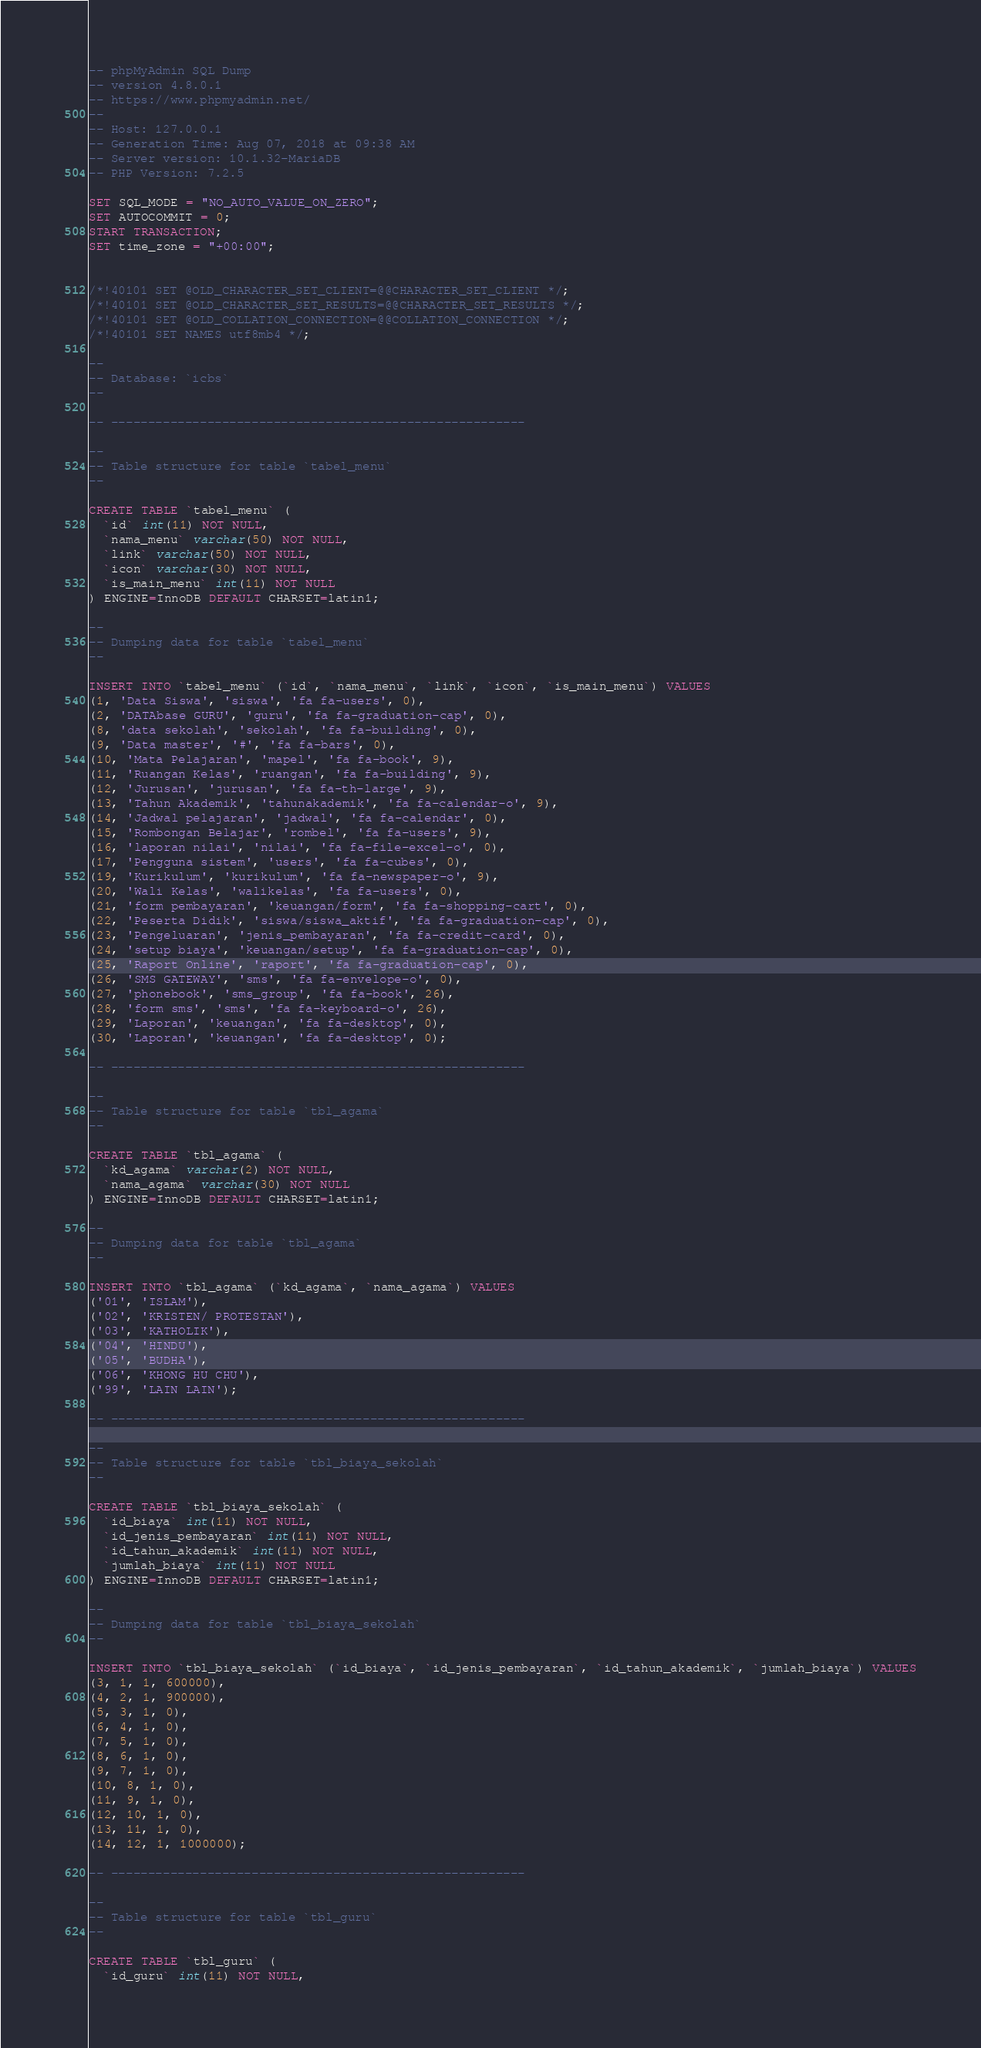<code> <loc_0><loc_0><loc_500><loc_500><_SQL_>-- phpMyAdmin SQL Dump
-- version 4.8.0.1
-- https://www.phpmyadmin.net/
--
-- Host: 127.0.0.1
-- Generation Time: Aug 07, 2018 at 09:38 AM
-- Server version: 10.1.32-MariaDB
-- PHP Version: 7.2.5

SET SQL_MODE = "NO_AUTO_VALUE_ON_ZERO";
SET AUTOCOMMIT = 0;
START TRANSACTION;
SET time_zone = "+00:00";


/*!40101 SET @OLD_CHARACTER_SET_CLIENT=@@CHARACTER_SET_CLIENT */;
/*!40101 SET @OLD_CHARACTER_SET_RESULTS=@@CHARACTER_SET_RESULTS */;
/*!40101 SET @OLD_COLLATION_CONNECTION=@@COLLATION_CONNECTION */;
/*!40101 SET NAMES utf8mb4 */;

--
-- Database: `icbs`
--

-- --------------------------------------------------------

--
-- Table structure for table `tabel_menu`
--

CREATE TABLE `tabel_menu` (
  `id` int(11) NOT NULL,
  `nama_menu` varchar(50) NOT NULL,
  `link` varchar(50) NOT NULL,
  `icon` varchar(30) NOT NULL,
  `is_main_menu` int(11) NOT NULL
) ENGINE=InnoDB DEFAULT CHARSET=latin1;

--
-- Dumping data for table `tabel_menu`
--

INSERT INTO `tabel_menu` (`id`, `nama_menu`, `link`, `icon`, `is_main_menu`) VALUES
(1, 'Data Siswa', 'siswa', 'fa fa-users', 0),
(2, 'DATAbase GURU', 'guru', 'fa fa-graduation-cap', 0),
(8, 'data sekolah', 'sekolah', 'fa fa-building', 0),
(9, 'Data master', '#', 'fa fa-bars', 0),
(10, 'Mata Pelajaran', 'mapel', 'fa fa-book', 9),
(11, 'Ruangan Kelas', 'ruangan', 'fa fa-building', 9),
(12, 'Jurusan', 'jurusan', 'fa fa-th-large', 9),
(13, 'Tahun Akademik', 'tahunakademik', 'fa fa-calendar-o', 9),
(14, 'Jadwal pelajaran', 'jadwal', 'fa fa-calendar', 0),
(15, 'Rombongan Belajar', 'rombel', 'fa fa-users', 9),
(16, 'laporan nilai', 'nilai', 'fa fa-file-excel-o', 0),
(17, 'Pengguna sistem', 'users', 'fa fa-cubes', 0),
(19, 'Kurikulum', 'kurikulum', 'fa fa-newspaper-o', 9),
(20, 'Wali Kelas', 'walikelas', 'fa fa-users', 0),
(21, 'form pembayaran', 'keuangan/form', 'fa fa-shopping-cart', 0),
(22, 'Peserta Didik', 'siswa/siswa_aktif', 'fa fa-graduation-cap', 0),
(23, 'Pengeluaran', 'jenis_pembayaran', 'fa fa-credit-card', 0),
(24, 'setup biaya', 'keuangan/setup', 'fa fa-graduation-cap', 0),
(25, 'Raport Online', 'raport', 'fa fa-graduation-cap', 0),
(26, 'SMS GATEWAY', 'sms', 'fa fa-envelope-o', 0),
(27, 'phonebook', 'sms_group', 'fa fa-book', 26),
(28, 'form sms', 'sms', 'fa fa-keyboard-o', 26),
(29, 'Laporan', 'keuangan', 'fa fa-desktop', 0),
(30, 'Laporan', 'keuangan', 'fa fa-desktop', 0);

-- --------------------------------------------------------

--
-- Table structure for table `tbl_agama`
--

CREATE TABLE `tbl_agama` (
  `kd_agama` varchar(2) NOT NULL,
  `nama_agama` varchar(30) NOT NULL
) ENGINE=InnoDB DEFAULT CHARSET=latin1;

--
-- Dumping data for table `tbl_agama`
--

INSERT INTO `tbl_agama` (`kd_agama`, `nama_agama`) VALUES
('01', 'ISLAM'),
('02', 'KRISTEN/ PROTESTAN'),
('03', 'KATHOLIK'),
('04', 'HINDU'),
('05', 'BUDHA'),
('06', 'KHONG HU CHU'),
('99', 'LAIN LAIN');

-- --------------------------------------------------------

--
-- Table structure for table `tbl_biaya_sekolah`
--

CREATE TABLE `tbl_biaya_sekolah` (
  `id_biaya` int(11) NOT NULL,
  `id_jenis_pembayaran` int(11) NOT NULL,
  `id_tahun_akademik` int(11) NOT NULL,
  `jumlah_biaya` int(11) NOT NULL
) ENGINE=InnoDB DEFAULT CHARSET=latin1;

--
-- Dumping data for table `tbl_biaya_sekolah`
--

INSERT INTO `tbl_biaya_sekolah` (`id_biaya`, `id_jenis_pembayaran`, `id_tahun_akademik`, `jumlah_biaya`) VALUES
(3, 1, 1, 600000),
(4, 2, 1, 900000),
(5, 3, 1, 0),
(6, 4, 1, 0),
(7, 5, 1, 0),
(8, 6, 1, 0),
(9, 7, 1, 0),
(10, 8, 1, 0),
(11, 9, 1, 0),
(12, 10, 1, 0),
(13, 11, 1, 0),
(14, 12, 1, 1000000);

-- --------------------------------------------------------

--
-- Table structure for table `tbl_guru`
--

CREATE TABLE `tbl_guru` (
  `id_guru` int(11) NOT NULL,</code> 